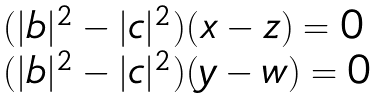Convert formula to latex. <formula><loc_0><loc_0><loc_500><loc_500>\begin{array} { l } ( | b | ^ { 2 } - | c | ^ { 2 } ) ( x - z ) = 0 \\ ( | b | ^ { 2 } - | c | ^ { 2 } ) ( y - w ) = 0 \\ \end{array}</formula> 